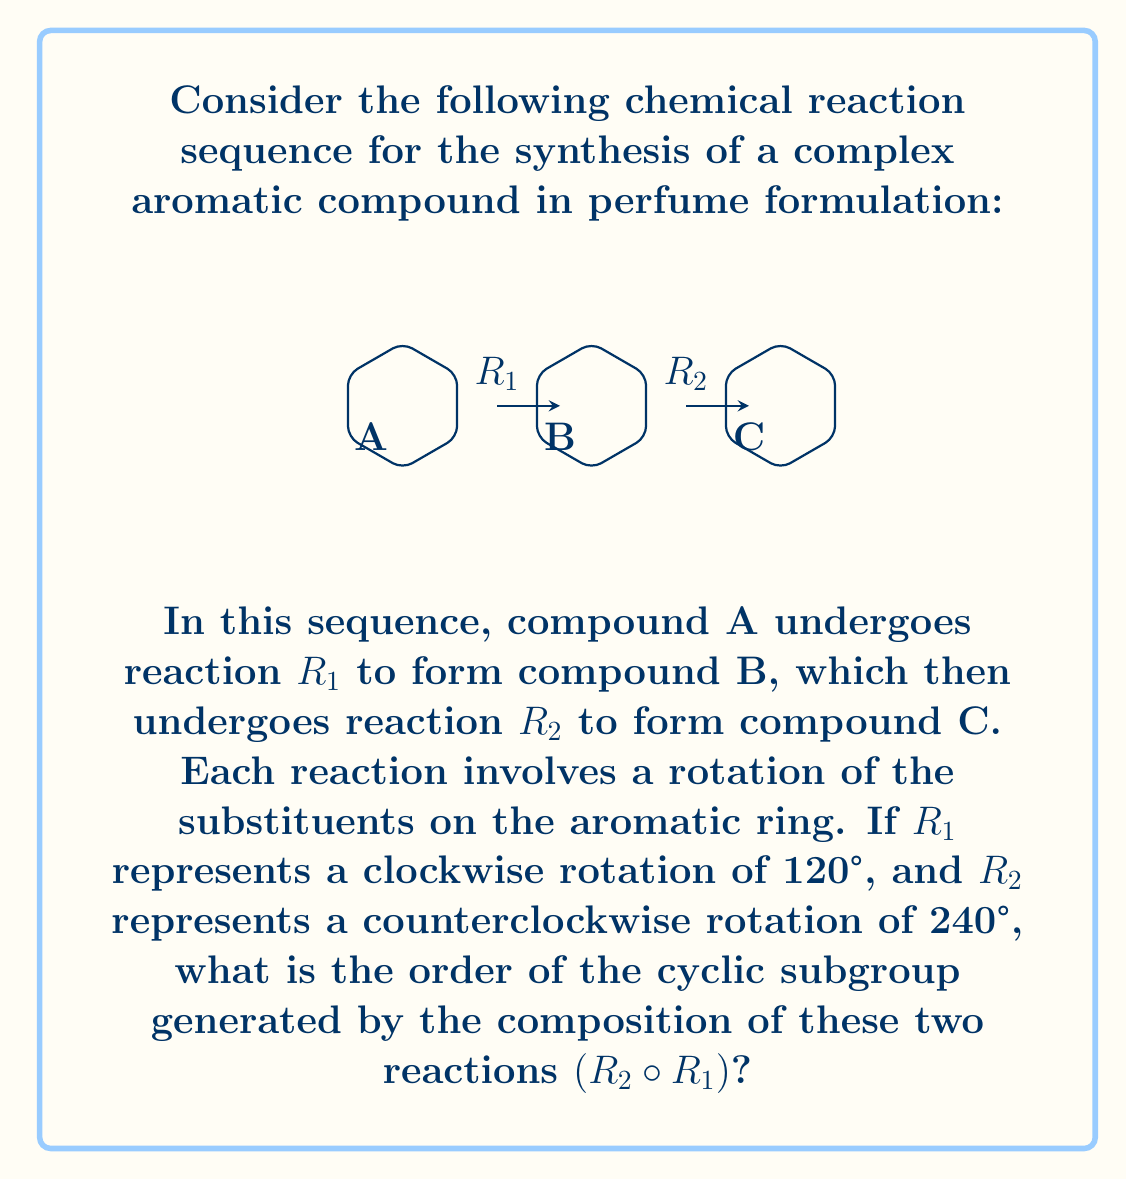Can you answer this question? Let's approach this step-by-step:

1) First, we need to understand what each reaction does:
   $R_1$: Clockwise rotation of 120° = 120°
   $R_2$: Counterclockwise rotation of 240° = -240°

2) The composition $R_2 \circ R_1$ means we apply $R_1$ first, then $R_2$. So:
   $R_2 \circ R_1 = -240° + 120° = -120°$

3) This means the composition $R_2 \circ R_1$ is equivalent to a counterclockwise rotation of 120°.

4) To find the order of the cyclic subgroup, we need to determine how many times we need to apply this rotation to get back to the starting position.

5) Let's apply the rotation multiple times:
   $(R_2 \circ R_1)^1 = -120°$
   $(R_2 \circ R_1)^2 = -240°$
   $(R_2 \circ R_1)^3 = -360° = 0°$

6) We see that after applying the composition three times, we get back to the starting position (0° or 360° rotation).

7) This means that the cyclic subgroup generated by $R_2 \circ R_1$ has order 3.

In group theory terms, this subgroup is isomorphic to $C_3$, the cyclic group of order 3.
Answer: 3 